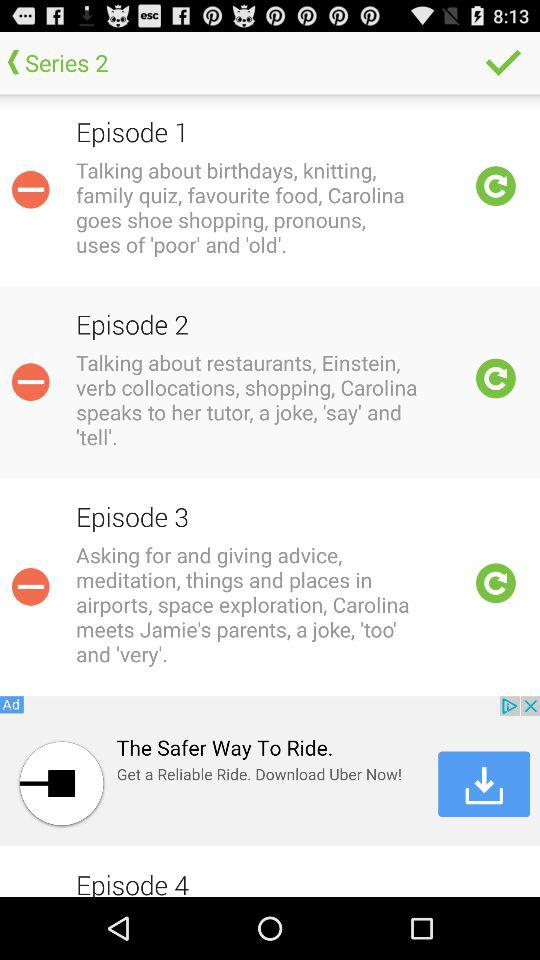How many episodes are there in the series?
Answer the question using a single word or phrase. 4 